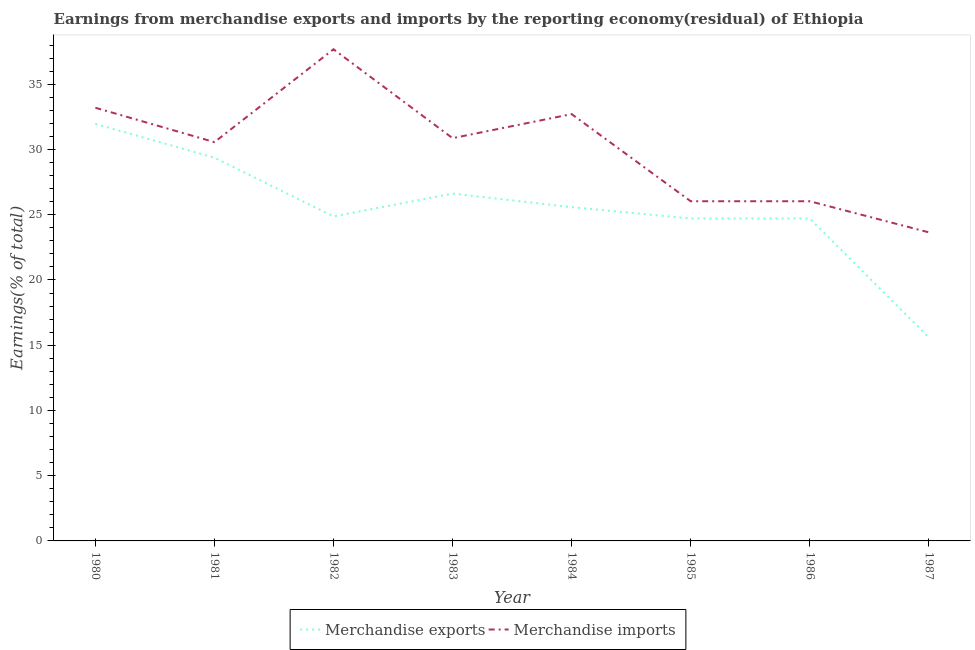Is the number of lines equal to the number of legend labels?
Offer a terse response. Yes. What is the earnings from merchandise imports in 1987?
Provide a succinct answer. 23.65. Across all years, what is the maximum earnings from merchandise exports?
Provide a succinct answer. 31.96. Across all years, what is the minimum earnings from merchandise imports?
Keep it short and to the point. 23.65. In which year was the earnings from merchandise exports maximum?
Offer a terse response. 1980. In which year was the earnings from merchandise imports minimum?
Provide a succinct answer. 1987. What is the total earnings from merchandise exports in the graph?
Offer a terse response. 203.43. What is the difference between the earnings from merchandise imports in 1982 and that in 1983?
Offer a terse response. 6.81. What is the difference between the earnings from merchandise imports in 1985 and the earnings from merchandise exports in 1980?
Your answer should be very brief. -5.93. What is the average earnings from merchandise exports per year?
Offer a very short reply. 25.43. In the year 1983, what is the difference between the earnings from merchandise imports and earnings from merchandise exports?
Provide a short and direct response. 4.25. In how many years, is the earnings from merchandise exports greater than 30 %?
Offer a terse response. 1. What is the ratio of the earnings from merchandise exports in 1980 to that in 1984?
Your response must be concise. 1.25. Is the earnings from merchandise imports in 1983 less than that in 1984?
Your answer should be very brief. Yes. What is the difference between the highest and the second highest earnings from merchandise exports?
Offer a very short reply. 2.59. What is the difference between the highest and the lowest earnings from merchandise imports?
Provide a succinct answer. 14.03. Is the earnings from merchandise imports strictly less than the earnings from merchandise exports over the years?
Provide a short and direct response. No. Are the values on the major ticks of Y-axis written in scientific E-notation?
Offer a very short reply. No. Does the graph contain any zero values?
Ensure brevity in your answer.  No. How many legend labels are there?
Your answer should be compact. 2. What is the title of the graph?
Offer a very short reply. Earnings from merchandise exports and imports by the reporting economy(residual) of Ethiopia. What is the label or title of the Y-axis?
Ensure brevity in your answer.  Earnings(% of total). What is the Earnings(% of total) in Merchandise exports in 1980?
Your response must be concise. 31.96. What is the Earnings(% of total) of Merchandise imports in 1980?
Ensure brevity in your answer.  33.2. What is the Earnings(% of total) in Merchandise exports in 1981?
Ensure brevity in your answer.  29.37. What is the Earnings(% of total) in Merchandise imports in 1981?
Give a very brief answer. 30.57. What is the Earnings(% of total) of Merchandise exports in 1982?
Give a very brief answer. 24.87. What is the Earnings(% of total) in Merchandise imports in 1982?
Provide a short and direct response. 37.68. What is the Earnings(% of total) in Merchandise exports in 1983?
Offer a very short reply. 26.62. What is the Earnings(% of total) in Merchandise imports in 1983?
Give a very brief answer. 30.87. What is the Earnings(% of total) of Merchandise exports in 1984?
Offer a terse response. 25.58. What is the Earnings(% of total) in Merchandise imports in 1984?
Give a very brief answer. 32.71. What is the Earnings(% of total) in Merchandise exports in 1985?
Ensure brevity in your answer.  24.71. What is the Earnings(% of total) of Merchandise imports in 1985?
Provide a short and direct response. 26.03. What is the Earnings(% of total) of Merchandise exports in 1986?
Offer a very short reply. 24.71. What is the Earnings(% of total) of Merchandise imports in 1986?
Give a very brief answer. 26.03. What is the Earnings(% of total) in Merchandise exports in 1987?
Provide a succinct answer. 15.6. What is the Earnings(% of total) in Merchandise imports in 1987?
Make the answer very short. 23.65. Across all years, what is the maximum Earnings(% of total) of Merchandise exports?
Keep it short and to the point. 31.96. Across all years, what is the maximum Earnings(% of total) in Merchandise imports?
Your answer should be very brief. 37.68. Across all years, what is the minimum Earnings(% of total) of Merchandise exports?
Provide a succinct answer. 15.6. Across all years, what is the minimum Earnings(% of total) of Merchandise imports?
Keep it short and to the point. 23.65. What is the total Earnings(% of total) of Merchandise exports in the graph?
Your response must be concise. 203.43. What is the total Earnings(% of total) of Merchandise imports in the graph?
Your response must be concise. 240.74. What is the difference between the Earnings(% of total) in Merchandise exports in 1980 and that in 1981?
Give a very brief answer. 2.59. What is the difference between the Earnings(% of total) in Merchandise imports in 1980 and that in 1981?
Keep it short and to the point. 2.63. What is the difference between the Earnings(% of total) in Merchandise exports in 1980 and that in 1982?
Provide a short and direct response. 7.09. What is the difference between the Earnings(% of total) in Merchandise imports in 1980 and that in 1982?
Provide a short and direct response. -4.48. What is the difference between the Earnings(% of total) in Merchandise exports in 1980 and that in 1983?
Your response must be concise. 5.34. What is the difference between the Earnings(% of total) of Merchandise imports in 1980 and that in 1983?
Keep it short and to the point. 2.33. What is the difference between the Earnings(% of total) of Merchandise exports in 1980 and that in 1984?
Offer a very short reply. 6.38. What is the difference between the Earnings(% of total) of Merchandise imports in 1980 and that in 1984?
Give a very brief answer. 0.49. What is the difference between the Earnings(% of total) of Merchandise exports in 1980 and that in 1985?
Your answer should be compact. 7.25. What is the difference between the Earnings(% of total) in Merchandise imports in 1980 and that in 1985?
Give a very brief answer. 7.17. What is the difference between the Earnings(% of total) of Merchandise exports in 1980 and that in 1986?
Your response must be concise. 7.25. What is the difference between the Earnings(% of total) of Merchandise imports in 1980 and that in 1986?
Provide a short and direct response. 7.17. What is the difference between the Earnings(% of total) in Merchandise exports in 1980 and that in 1987?
Provide a succinct answer. 16.36. What is the difference between the Earnings(% of total) of Merchandise imports in 1980 and that in 1987?
Provide a short and direct response. 9.55. What is the difference between the Earnings(% of total) of Merchandise exports in 1981 and that in 1982?
Provide a succinct answer. 4.5. What is the difference between the Earnings(% of total) of Merchandise imports in 1981 and that in 1982?
Offer a very short reply. -7.11. What is the difference between the Earnings(% of total) in Merchandise exports in 1981 and that in 1983?
Your answer should be very brief. 2.75. What is the difference between the Earnings(% of total) in Merchandise imports in 1981 and that in 1983?
Your answer should be very brief. -0.3. What is the difference between the Earnings(% of total) in Merchandise exports in 1981 and that in 1984?
Provide a short and direct response. 3.79. What is the difference between the Earnings(% of total) in Merchandise imports in 1981 and that in 1984?
Make the answer very short. -2.15. What is the difference between the Earnings(% of total) in Merchandise exports in 1981 and that in 1985?
Offer a terse response. 4.66. What is the difference between the Earnings(% of total) in Merchandise imports in 1981 and that in 1985?
Make the answer very short. 4.53. What is the difference between the Earnings(% of total) in Merchandise exports in 1981 and that in 1986?
Keep it short and to the point. 4.66. What is the difference between the Earnings(% of total) in Merchandise imports in 1981 and that in 1986?
Give a very brief answer. 4.53. What is the difference between the Earnings(% of total) in Merchandise exports in 1981 and that in 1987?
Give a very brief answer. 13.77. What is the difference between the Earnings(% of total) in Merchandise imports in 1981 and that in 1987?
Provide a short and direct response. 6.91. What is the difference between the Earnings(% of total) of Merchandise exports in 1982 and that in 1983?
Keep it short and to the point. -1.75. What is the difference between the Earnings(% of total) in Merchandise imports in 1982 and that in 1983?
Give a very brief answer. 6.81. What is the difference between the Earnings(% of total) in Merchandise exports in 1982 and that in 1984?
Give a very brief answer. -0.71. What is the difference between the Earnings(% of total) in Merchandise imports in 1982 and that in 1984?
Provide a succinct answer. 4.97. What is the difference between the Earnings(% of total) in Merchandise exports in 1982 and that in 1985?
Provide a short and direct response. 0.16. What is the difference between the Earnings(% of total) in Merchandise imports in 1982 and that in 1985?
Your answer should be very brief. 11.65. What is the difference between the Earnings(% of total) of Merchandise exports in 1982 and that in 1986?
Provide a succinct answer. 0.16. What is the difference between the Earnings(% of total) in Merchandise imports in 1982 and that in 1986?
Keep it short and to the point. 11.65. What is the difference between the Earnings(% of total) in Merchandise exports in 1982 and that in 1987?
Offer a terse response. 9.27. What is the difference between the Earnings(% of total) of Merchandise imports in 1982 and that in 1987?
Ensure brevity in your answer.  14.03. What is the difference between the Earnings(% of total) in Merchandise exports in 1983 and that in 1984?
Provide a short and direct response. 1.04. What is the difference between the Earnings(% of total) of Merchandise imports in 1983 and that in 1984?
Offer a very short reply. -1.85. What is the difference between the Earnings(% of total) in Merchandise exports in 1983 and that in 1985?
Provide a succinct answer. 1.91. What is the difference between the Earnings(% of total) of Merchandise imports in 1983 and that in 1985?
Keep it short and to the point. 4.83. What is the difference between the Earnings(% of total) of Merchandise exports in 1983 and that in 1986?
Keep it short and to the point. 1.91. What is the difference between the Earnings(% of total) in Merchandise imports in 1983 and that in 1986?
Provide a succinct answer. 4.83. What is the difference between the Earnings(% of total) in Merchandise exports in 1983 and that in 1987?
Provide a short and direct response. 11.02. What is the difference between the Earnings(% of total) in Merchandise imports in 1983 and that in 1987?
Your answer should be compact. 7.22. What is the difference between the Earnings(% of total) of Merchandise exports in 1984 and that in 1985?
Provide a succinct answer. 0.87. What is the difference between the Earnings(% of total) in Merchandise imports in 1984 and that in 1985?
Your answer should be compact. 6.68. What is the difference between the Earnings(% of total) in Merchandise exports in 1984 and that in 1986?
Offer a very short reply. 0.87. What is the difference between the Earnings(% of total) in Merchandise imports in 1984 and that in 1986?
Your answer should be very brief. 6.68. What is the difference between the Earnings(% of total) in Merchandise exports in 1984 and that in 1987?
Your response must be concise. 9.98. What is the difference between the Earnings(% of total) in Merchandise imports in 1984 and that in 1987?
Provide a succinct answer. 9.06. What is the difference between the Earnings(% of total) in Merchandise imports in 1985 and that in 1986?
Offer a terse response. 0. What is the difference between the Earnings(% of total) of Merchandise exports in 1985 and that in 1987?
Offer a terse response. 9.11. What is the difference between the Earnings(% of total) in Merchandise imports in 1985 and that in 1987?
Offer a terse response. 2.38. What is the difference between the Earnings(% of total) of Merchandise exports in 1986 and that in 1987?
Offer a very short reply. 9.11. What is the difference between the Earnings(% of total) of Merchandise imports in 1986 and that in 1987?
Make the answer very short. 2.38. What is the difference between the Earnings(% of total) of Merchandise exports in 1980 and the Earnings(% of total) of Merchandise imports in 1981?
Offer a terse response. 1.4. What is the difference between the Earnings(% of total) of Merchandise exports in 1980 and the Earnings(% of total) of Merchandise imports in 1982?
Make the answer very short. -5.72. What is the difference between the Earnings(% of total) of Merchandise exports in 1980 and the Earnings(% of total) of Merchandise imports in 1983?
Your answer should be compact. 1.1. What is the difference between the Earnings(% of total) in Merchandise exports in 1980 and the Earnings(% of total) in Merchandise imports in 1984?
Offer a very short reply. -0.75. What is the difference between the Earnings(% of total) in Merchandise exports in 1980 and the Earnings(% of total) in Merchandise imports in 1985?
Give a very brief answer. 5.93. What is the difference between the Earnings(% of total) in Merchandise exports in 1980 and the Earnings(% of total) in Merchandise imports in 1986?
Provide a short and direct response. 5.93. What is the difference between the Earnings(% of total) in Merchandise exports in 1980 and the Earnings(% of total) in Merchandise imports in 1987?
Make the answer very short. 8.31. What is the difference between the Earnings(% of total) of Merchandise exports in 1981 and the Earnings(% of total) of Merchandise imports in 1982?
Your answer should be compact. -8.31. What is the difference between the Earnings(% of total) of Merchandise exports in 1981 and the Earnings(% of total) of Merchandise imports in 1983?
Provide a succinct answer. -1.5. What is the difference between the Earnings(% of total) in Merchandise exports in 1981 and the Earnings(% of total) in Merchandise imports in 1984?
Your response must be concise. -3.34. What is the difference between the Earnings(% of total) of Merchandise exports in 1981 and the Earnings(% of total) of Merchandise imports in 1985?
Make the answer very short. 3.34. What is the difference between the Earnings(% of total) in Merchandise exports in 1981 and the Earnings(% of total) in Merchandise imports in 1986?
Your answer should be very brief. 3.34. What is the difference between the Earnings(% of total) of Merchandise exports in 1981 and the Earnings(% of total) of Merchandise imports in 1987?
Your answer should be compact. 5.72. What is the difference between the Earnings(% of total) in Merchandise exports in 1982 and the Earnings(% of total) in Merchandise imports in 1983?
Your answer should be compact. -6. What is the difference between the Earnings(% of total) of Merchandise exports in 1982 and the Earnings(% of total) of Merchandise imports in 1984?
Your response must be concise. -7.84. What is the difference between the Earnings(% of total) in Merchandise exports in 1982 and the Earnings(% of total) in Merchandise imports in 1985?
Offer a terse response. -1.16. What is the difference between the Earnings(% of total) of Merchandise exports in 1982 and the Earnings(% of total) of Merchandise imports in 1986?
Provide a succinct answer. -1.16. What is the difference between the Earnings(% of total) of Merchandise exports in 1982 and the Earnings(% of total) of Merchandise imports in 1987?
Provide a succinct answer. 1.22. What is the difference between the Earnings(% of total) in Merchandise exports in 1983 and the Earnings(% of total) in Merchandise imports in 1984?
Keep it short and to the point. -6.09. What is the difference between the Earnings(% of total) in Merchandise exports in 1983 and the Earnings(% of total) in Merchandise imports in 1985?
Keep it short and to the point. 0.59. What is the difference between the Earnings(% of total) of Merchandise exports in 1983 and the Earnings(% of total) of Merchandise imports in 1986?
Make the answer very short. 0.59. What is the difference between the Earnings(% of total) in Merchandise exports in 1983 and the Earnings(% of total) in Merchandise imports in 1987?
Offer a terse response. 2.97. What is the difference between the Earnings(% of total) of Merchandise exports in 1984 and the Earnings(% of total) of Merchandise imports in 1985?
Ensure brevity in your answer.  -0.45. What is the difference between the Earnings(% of total) in Merchandise exports in 1984 and the Earnings(% of total) in Merchandise imports in 1986?
Provide a succinct answer. -0.45. What is the difference between the Earnings(% of total) in Merchandise exports in 1984 and the Earnings(% of total) in Merchandise imports in 1987?
Your answer should be compact. 1.93. What is the difference between the Earnings(% of total) in Merchandise exports in 1985 and the Earnings(% of total) in Merchandise imports in 1986?
Provide a succinct answer. -1.32. What is the difference between the Earnings(% of total) of Merchandise exports in 1985 and the Earnings(% of total) of Merchandise imports in 1987?
Ensure brevity in your answer.  1.06. What is the difference between the Earnings(% of total) in Merchandise exports in 1986 and the Earnings(% of total) in Merchandise imports in 1987?
Provide a short and direct response. 1.06. What is the average Earnings(% of total) in Merchandise exports per year?
Your response must be concise. 25.43. What is the average Earnings(% of total) in Merchandise imports per year?
Keep it short and to the point. 30.09. In the year 1980, what is the difference between the Earnings(% of total) in Merchandise exports and Earnings(% of total) in Merchandise imports?
Your response must be concise. -1.24. In the year 1981, what is the difference between the Earnings(% of total) in Merchandise exports and Earnings(% of total) in Merchandise imports?
Keep it short and to the point. -1.19. In the year 1982, what is the difference between the Earnings(% of total) of Merchandise exports and Earnings(% of total) of Merchandise imports?
Make the answer very short. -12.81. In the year 1983, what is the difference between the Earnings(% of total) of Merchandise exports and Earnings(% of total) of Merchandise imports?
Your response must be concise. -4.25. In the year 1984, what is the difference between the Earnings(% of total) of Merchandise exports and Earnings(% of total) of Merchandise imports?
Provide a succinct answer. -7.13. In the year 1985, what is the difference between the Earnings(% of total) in Merchandise exports and Earnings(% of total) in Merchandise imports?
Your answer should be compact. -1.32. In the year 1986, what is the difference between the Earnings(% of total) of Merchandise exports and Earnings(% of total) of Merchandise imports?
Offer a terse response. -1.32. In the year 1987, what is the difference between the Earnings(% of total) in Merchandise exports and Earnings(% of total) in Merchandise imports?
Ensure brevity in your answer.  -8.05. What is the ratio of the Earnings(% of total) of Merchandise exports in 1980 to that in 1981?
Your answer should be very brief. 1.09. What is the ratio of the Earnings(% of total) in Merchandise imports in 1980 to that in 1981?
Ensure brevity in your answer.  1.09. What is the ratio of the Earnings(% of total) in Merchandise exports in 1980 to that in 1982?
Give a very brief answer. 1.29. What is the ratio of the Earnings(% of total) of Merchandise imports in 1980 to that in 1982?
Keep it short and to the point. 0.88. What is the ratio of the Earnings(% of total) in Merchandise exports in 1980 to that in 1983?
Offer a very short reply. 1.2. What is the ratio of the Earnings(% of total) of Merchandise imports in 1980 to that in 1983?
Give a very brief answer. 1.08. What is the ratio of the Earnings(% of total) of Merchandise exports in 1980 to that in 1984?
Offer a terse response. 1.25. What is the ratio of the Earnings(% of total) of Merchandise imports in 1980 to that in 1984?
Make the answer very short. 1.01. What is the ratio of the Earnings(% of total) of Merchandise exports in 1980 to that in 1985?
Your response must be concise. 1.29. What is the ratio of the Earnings(% of total) in Merchandise imports in 1980 to that in 1985?
Provide a succinct answer. 1.28. What is the ratio of the Earnings(% of total) of Merchandise exports in 1980 to that in 1986?
Provide a succinct answer. 1.29. What is the ratio of the Earnings(% of total) of Merchandise imports in 1980 to that in 1986?
Give a very brief answer. 1.28. What is the ratio of the Earnings(% of total) of Merchandise exports in 1980 to that in 1987?
Provide a succinct answer. 2.05. What is the ratio of the Earnings(% of total) of Merchandise imports in 1980 to that in 1987?
Provide a short and direct response. 1.4. What is the ratio of the Earnings(% of total) in Merchandise exports in 1981 to that in 1982?
Give a very brief answer. 1.18. What is the ratio of the Earnings(% of total) of Merchandise imports in 1981 to that in 1982?
Offer a terse response. 0.81. What is the ratio of the Earnings(% of total) of Merchandise exports in 1981 to that in 1983?
Make the answer very short. 1.1. What is the ratio of the Earnings(% of total) of Merchandise imports in 1981 to that in 1983?
Your answer should be compact. 0.99. What is the ratio of the Earnings(% of total) of Merchandise exports in 1981 to that in 1984?
Provide a succinct answer. 1.15. What is the ratio of the Earnings(% of total) in Merchandise imports in 1981 to that in 1984?
Provide a succinct answer. 0.93. What is the ratio of the Earnings(% of total) of Merchandise exports in 1981 to that in 1985?
Your answer should be very brief. 1.19. What is the ratio of the Earnings(% of total) in Merchandise imports in 1981 to that in 1985?
Offer a very short reply. 1.17. What is the ratio of the Earnings(% of total) of Merchandise exports in 1981 to that in 1986?
Keep it short and to the point. 1.19. What is the ratio of the Earnings(% of total) of Merchandise imports in 1981 to that in 1986?
Keep it short and to the point. 1.17. What is the ratio of the Earnings(% of total) in Merchandise exports in 1981 to that in 1987?
Provide a succinct answer. 1.88. What is the ratio of the Earnings(% of total) of Merchandise imports in 1981 to that in 1987?
Provide a short and direct response. 1.29. What is the ratio of the Earnings(% of total) in Merchandise exports in 1982 to that in 1983?
Provide a succinct answer. 0.93. What is the ratio of the Earnings(% of total) of Merchandise imports in 1982 to that in 1983?
Keep it short and to the point. 1.22. What is the ratio of the Earnings(% of total) of Merchandise exports in 1982 to that in 1984?
Make the answer very short. 0.97. What is the ratio of the Earnings(% of total) of Merchandise imports in 1982 to that in 1984?
Offer a very short reply. 1.15. What is the ratio of the Earnings(% of total) in Merchandise exports in 1982 to that in 1985?
Provide a short and direct response. 1.01. What is the ratio of the Earnings(% of total) of Merchandise imports in 1982 to that in 1985?
Give a very brief answer. 1.45. What is the ratio of the Earnings(% of total) of Merchandise exports in 1982 to that in 1986?
Ensure brevity in your answer.  1.01. What is the ratio of the Earnings(% of total) in Merchandise imports in 1982 to that in 1986?
Provide a short and direct response. 1.45. What is the ratio of the Earnings(% of total) in Merchandise exports in 1982 to that in 1987?
Offer a very short reply. 1.59. What is the ratio of the Earnings(% of total) of Merchandise imports in 1982 to that in 1987?
Your response must be concise. 1.59. What is the ratio of the Earnings(% of total) in Merchandise exports in 1983 to that in 1984?
Give a very brief answer. 1.04. What is the ratio of the Earnings(% of total) in Merchandise imports in 1983 to that in 1984?
Give a very brief answer. 0.94. What is the ratio of the Earnings(% of total) in Merchandise exports in 1983 to that in 1985?
Give a very brief answer. 1.08. What is the ratio of the Earnings(% of total) of Merchandise imports in 1983 to that in 1985?
Offer a very short reply. 1.19. What is the ratio of the Earnings(% of total) in Merchandise exports in 1983 to that in 1986?
Your response must be concise. 1.08. What is the ratio of the Earnings(% of total) of Merchandise imports in 1983 to that in 1986?
Your answer should be compact. 1.19. What is the ratio of the Earnings(% of total) of Merchandise exports in 1983 to that in 1987?
Ensure brevity in your answer.  1.71. What is the ratio of the Earnings(% of total) in Merchandise imports in 1983 to that in 1987?
Your response must be concise. 1.31. What is the ratio of the Earnings(% of total) in Merchandise exports in 1984 to that in 1985?
Provide a short and direct response. 1.04. What is the ratio of the Earnings(% of total) in Merchandise imports in 1984 to that in 1985?
Your answer should be very brief. 1.26. What is the ratio of the Earnings(% of total) of Merchandise exports in 1984 to that in 1986?
Provide a succinct answer. 1.04. What is the ratio of the Earnings(% of total) of Merchandise imports in 1984 to that in 1986?
Ensure brevity in your answer.  1.26. What is the ratio of the Earnings(% of total) of Merchandise exports in 1984 to that in 1987?
Ensure brevity in your answer.  1.64. What is the ratio of the Earnings(% of total) of Merchandise imports in 1984 to that in 1987?
Make the answer very short. 1.38. What is the ratio of the Earnings(% of total) of Merchandise exports in 1985 to that in 1986?
Provide a short and direct response. 1. What is the ratio of the Earnings(% of total) in Merchandise imports in 1985 to that in 1986?
Offer a very short reply. 1. What is the ratio of the Earnings(% of total) of Merchandise exports in 1985 to that in 1987?
Give a very brief answer. 1.58. What is the ratio of the Earnings(% of total) of Merchandise imports in 1985 to that in 1987?
Ensure brevity in your answer.  1.1. What is the ratio of the Earnings(% of total) of Merchandise exports in 1986 to that in 1987?
Make the answer very short. 1.58. What is the ratio of the Earnings(% of total) of Merchandise imports in 1986 to that in 1987?
Offer a very short reply. 1.1. What is the difference between the highest and the second highest Earnings(% of total) in Merchandise exports?
Provide a short and direct response. 2.59. What is the difference between the highest and the second highest Earnings(% of total) in Merchandise imports?
Your answer should be compact. 4.48. What is the difference between the highest and the lowest Earnings(% of total) in Merchandise exports?
Offer a very short reply. 16.36. What is the difference between the highest and the lowest Earnings(% of total) in Merchandise imports?
Provide a succinct answer. 14.03. 